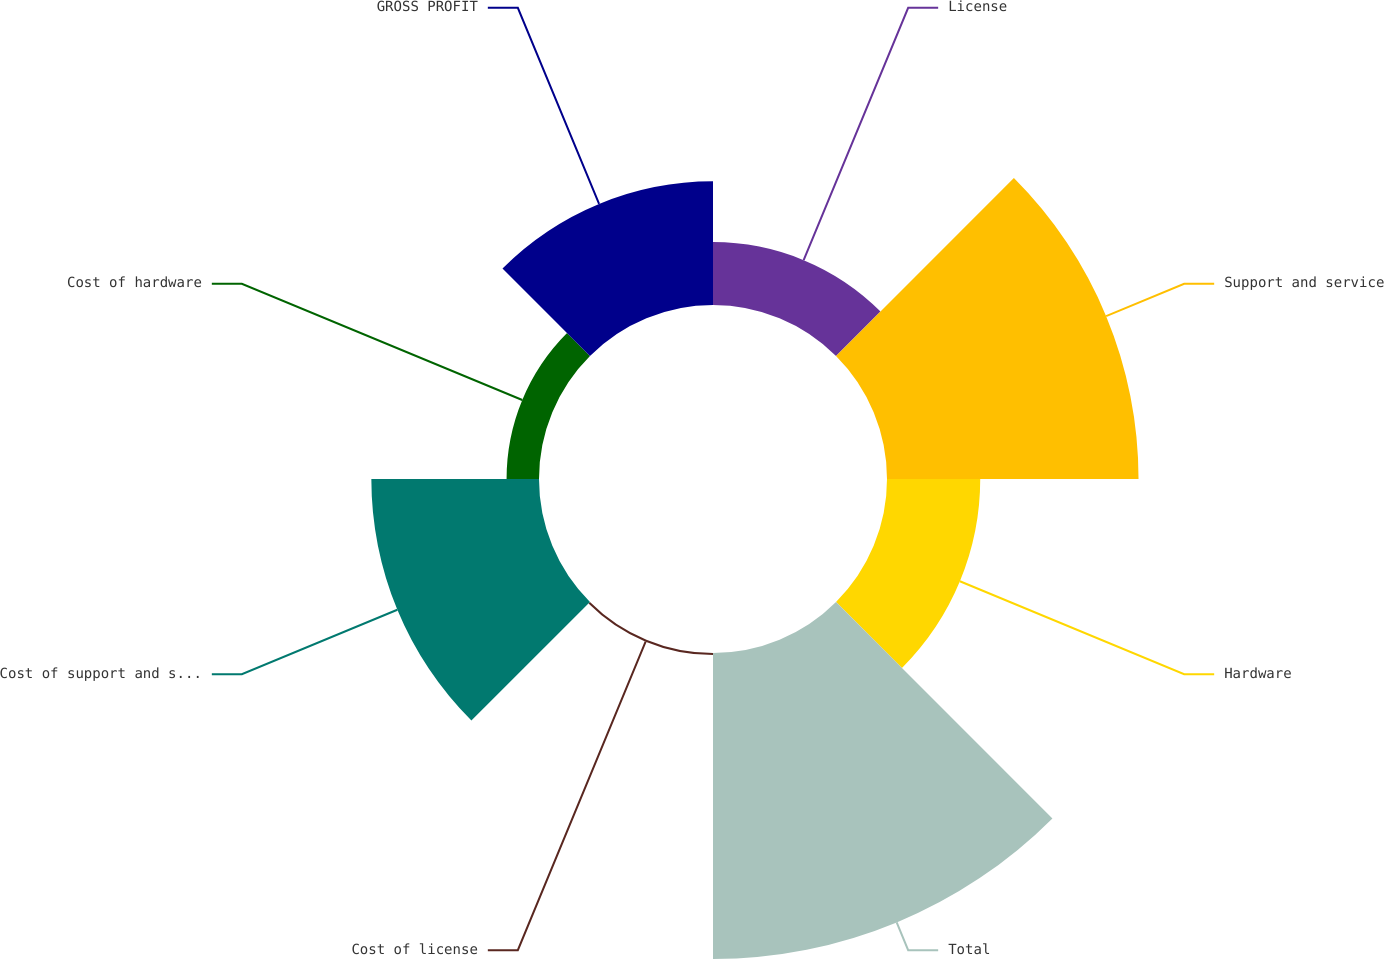Convert chart. <chart><loc_0><loc_0><loc_500><loc_500><pie_chart><fcel>License<fcel>Support and service<fcel>Hardware<fcel>Total<fcel>Cost of license<fcel>Cost of support and service<fcel>Cost of hardware<fcel>GROSS PROFIT<nl><fcel>6.05%<fcel>24.2%<fcel>8.97%<fcel>29.44%<fcel>0.2%<fcel>16.13%<fcel>3.12%<fcel>11.9%<nl></chart> 